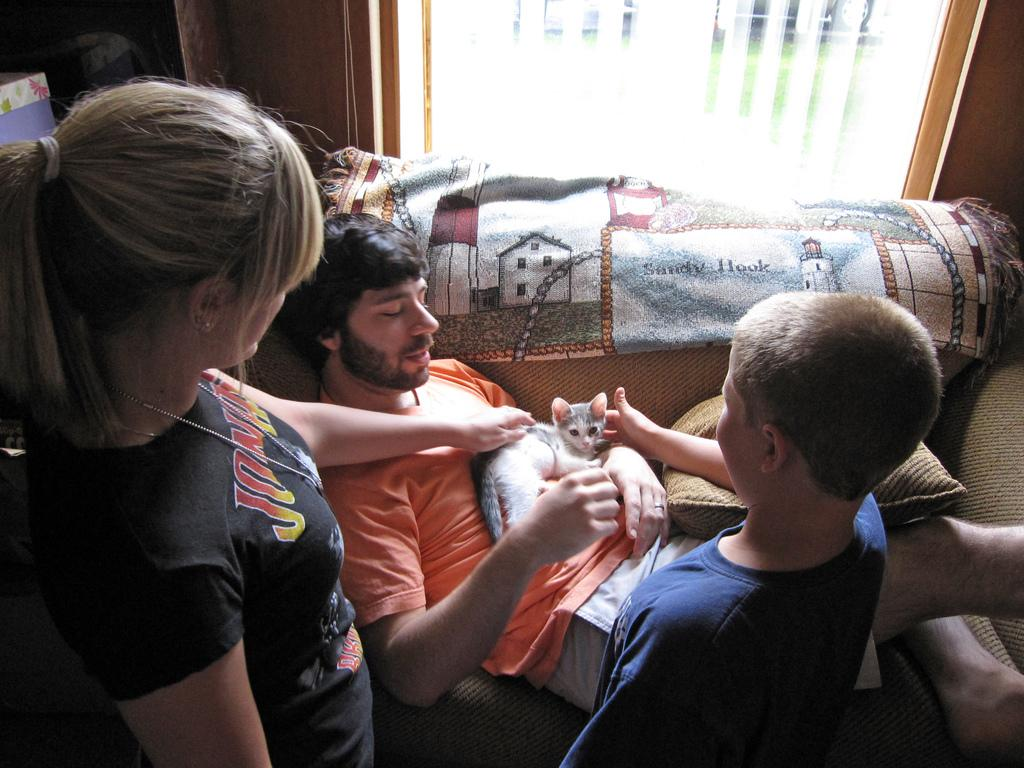What is the man in the image doing? The man is laying on the sofa in the image. What is on top of the man? A cat is on the man. How many children are in the image? There is a girl and a boy in the image. What object can be seen on the side in the image? There is a pillow on the side in the image. What type of argument is taking place between the father and the children in the image? There is no father present in the image, and no argument is taking place. What kind of canvas is visible in the image? There is no canvas present in the image. 